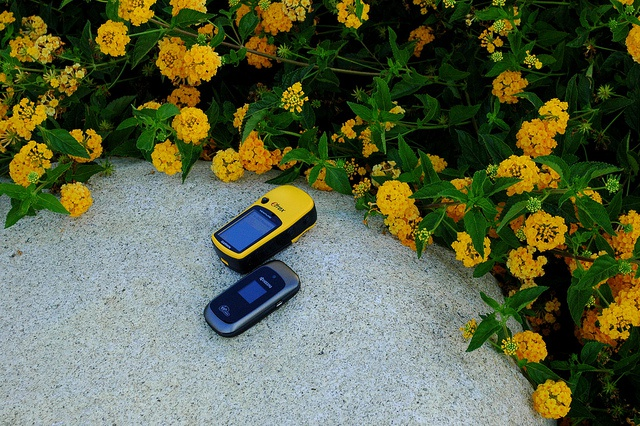Describe the objects in this image and their specific colors. I can see cell phone in black, gold, blue, and navy tones and cell phone in black, navy, gray, and darkblue tones in this image. 